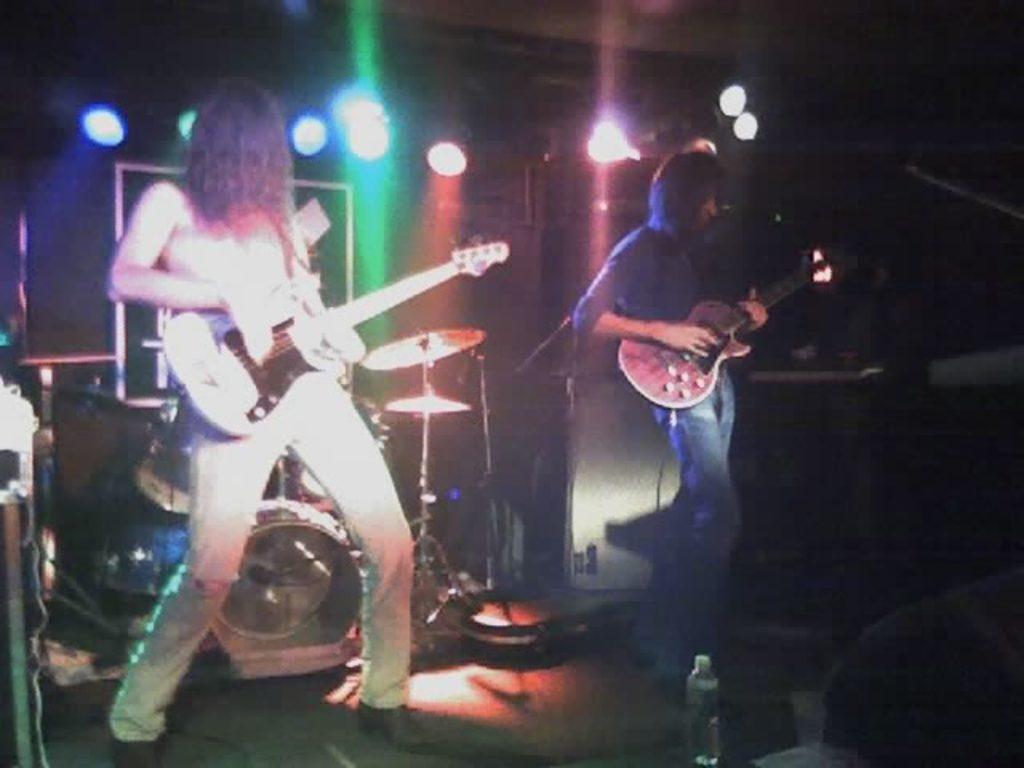Could you give a brief overview of what you see in this image? In this image on the right side there is one person who is standing and he is holding a guitar and on the left side there is one person who is standing and he is also holding a guitar. On the background there are some drums. On the floor there is one bottle on the top there are some lights. 